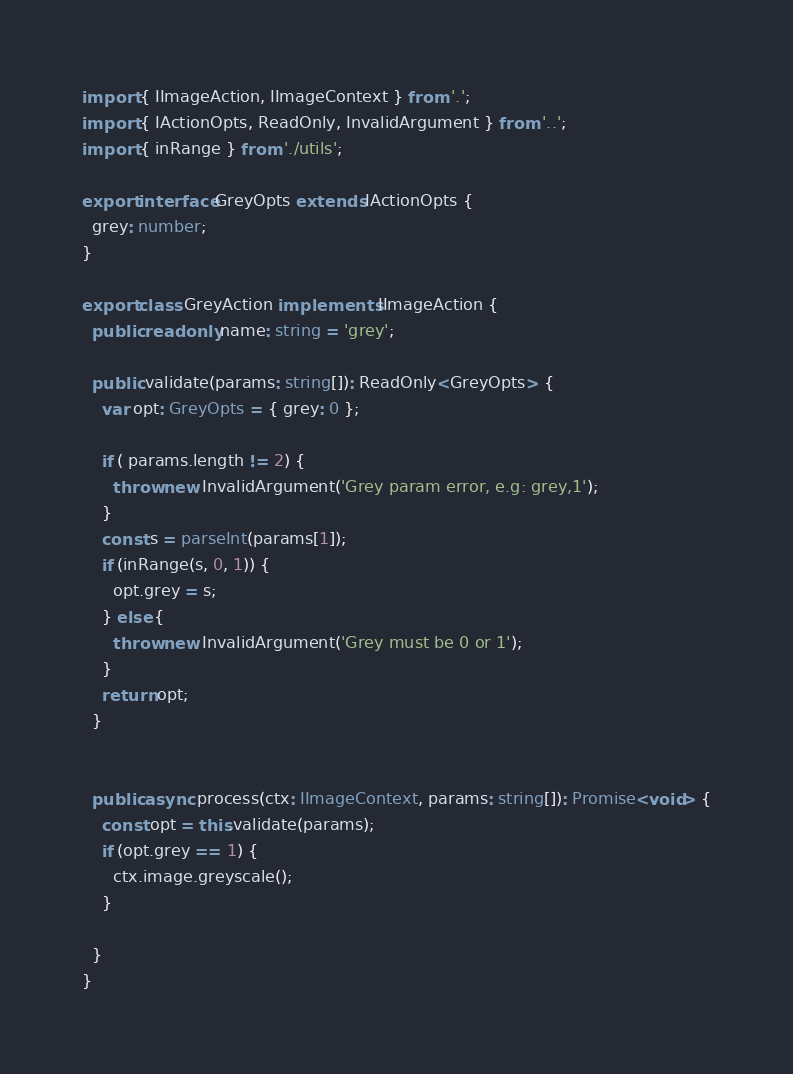<code> <loc_0><loc_0><loc_500><loc_500><_TypeScript_>import { IImageAction, IImageContext } from '.';
import { IActionOpts, ReadOnly, InvalidArgument } from '..';
import { inRange } from './utils';

export interface GreyOpts extends IActionOpts {
  grey: number;
}

export class GreyAction implements IImageAction {
  public readonly name: string = 'grey';

  public validate(params: string[]): ReadOnly<GreyOpts> {
    var opt: GreyOpts = { grey: 0 };

    if ( params.length != 2) {
      throw new InvalidArgument('Grey param error, e.g: grey,1');
    }
    const s = parseInt(params[1]);
    if (inRange(s, 0, 1)) {
      opt.grey = s;
    } else {
      throw new InvalidArgument('Grey must be 0 or 1');
    }
    return opt;
  }


  public async process(ctx: IImageContext, params: string[]): Promise<void> {
    const opt = this.validate(params);
    if (opt.grey == 1) {
      ctx.image.greyscale();
    }

  }
}</code> 